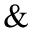Convert formula to latex. <formula><loc_0><loc_0><loc_500><loc_500>\&</formula> 